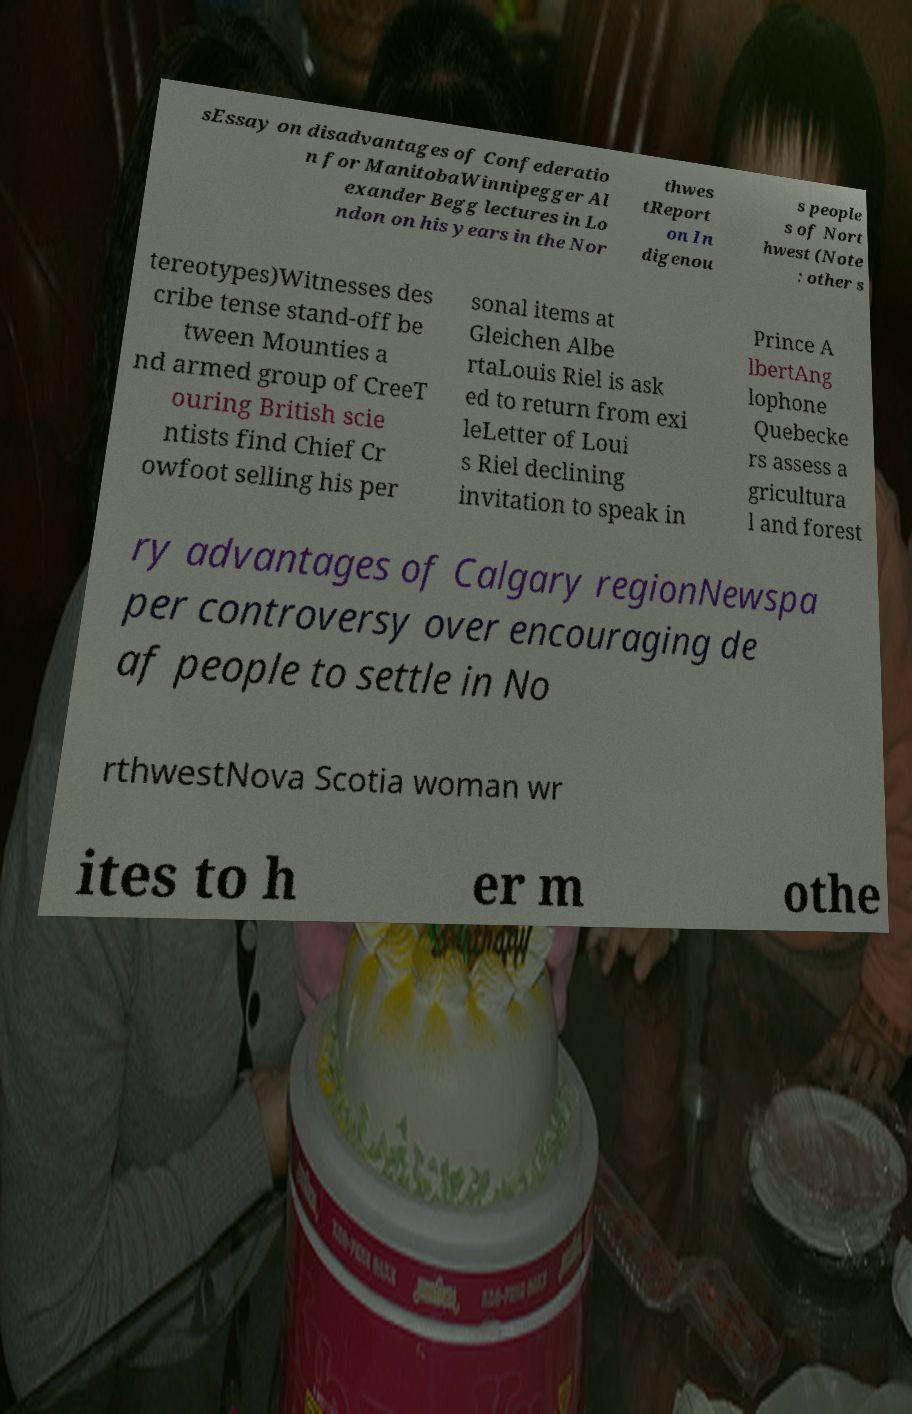Can you accurately transcribe the text from the provided image for me? sEssay on disadvantages of Confederatio n for ManitobaWinnipegger Al exander Begg lectures in Lo ndon on his years in the Nor thwes tReport on In digenou s people s of Nort hwest (Note : other s tereotypes)Witnesses des cribe tense stand-off be tween Mounties a nd armed group of CreeT ouring British scie ntists find Chief Cr owfoot selling his per sonal items at Gleichen Albe rtaLouis Riel is ask ed to return from exi leLetter of Loui s Riel declining invitation to speak in Prince A lbertAng lophone Quebecke rs assess a gricultura l and forest ry advantages of Calgary regionNewspa per controversy over encouraging de af people to settle in No rthwestNova Scotia woman wr ites to h er m othe 